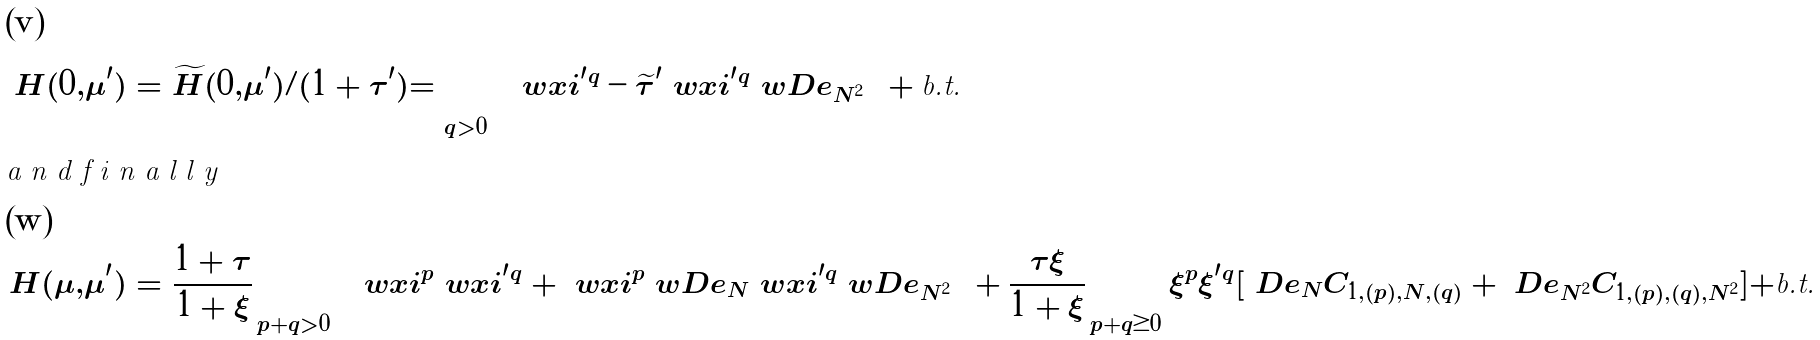Convert formula to latex. <formula><loc_0><loc_0><loc_500><loc_500>H ( 0 , \mu ^ { \prime } ) & = \widetilde { H } ( 0 , \mu ^ { \prime } ) / ( 1 + \tau ^ { \prime } ) = \sum _ { q > 0 } \left ( \ w x i ^ { \prime } \null ^ { q } - \widetilde { \tau } ^ { \prime } \ w x i ^ { \prime } \null ^ { q } \ w D e _ { N ^ { 2 } } \right ) + \text {b.t.} \\ \intertext { a n d f i n a l l y } H ( \mu , \mu ^ { \prime } ) & = \frac { 1 + \tau } { 1 + \xi } \sum _ { p + q > 0 } \left ( \ w x i ^ { p } \ w x i ^ { \prime } \null ^ { q } + \ w x i ^ { p } \ w D e _ { N } \ w x i ^ { \prime } \null ^ { q } \ w D e _ { N ^ { 2 } } \right ) + \frac { \tau \xi } { 1 + \xi } \sum _ { p + q \geq 0 } \xi ^ { p } \xi ^ { \prime } \null ^ { q } [ \ D e _ { N } C _ { 1 , ( p ) , N , ( q ) } + \ D e _ { N ^ { 2 } } C _ { 1 , ( p ) , ( q ) , N ^ { 2 } } ] + \text {b.t.}</formula> 